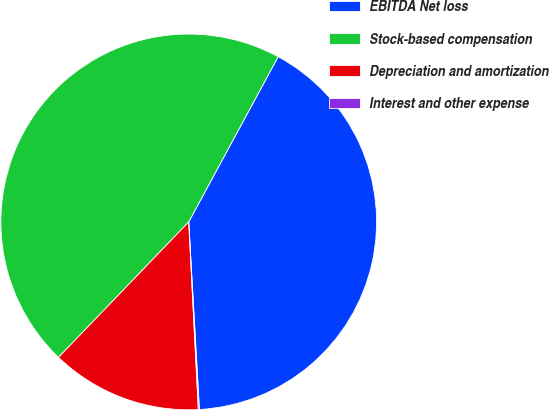Convert chart. <chart><loc_0><loc_0><loc_500><loc_500><pie_chart><fcel>EBITDA Net loss<fcel>Stock-based compensation<fcel>Depreciation and amortization<fcel>Interest and other expense<nl><fcel>41.2%<fcel>45.71%<fcel>13.0%<fcel>0.09%<nl></chart> 